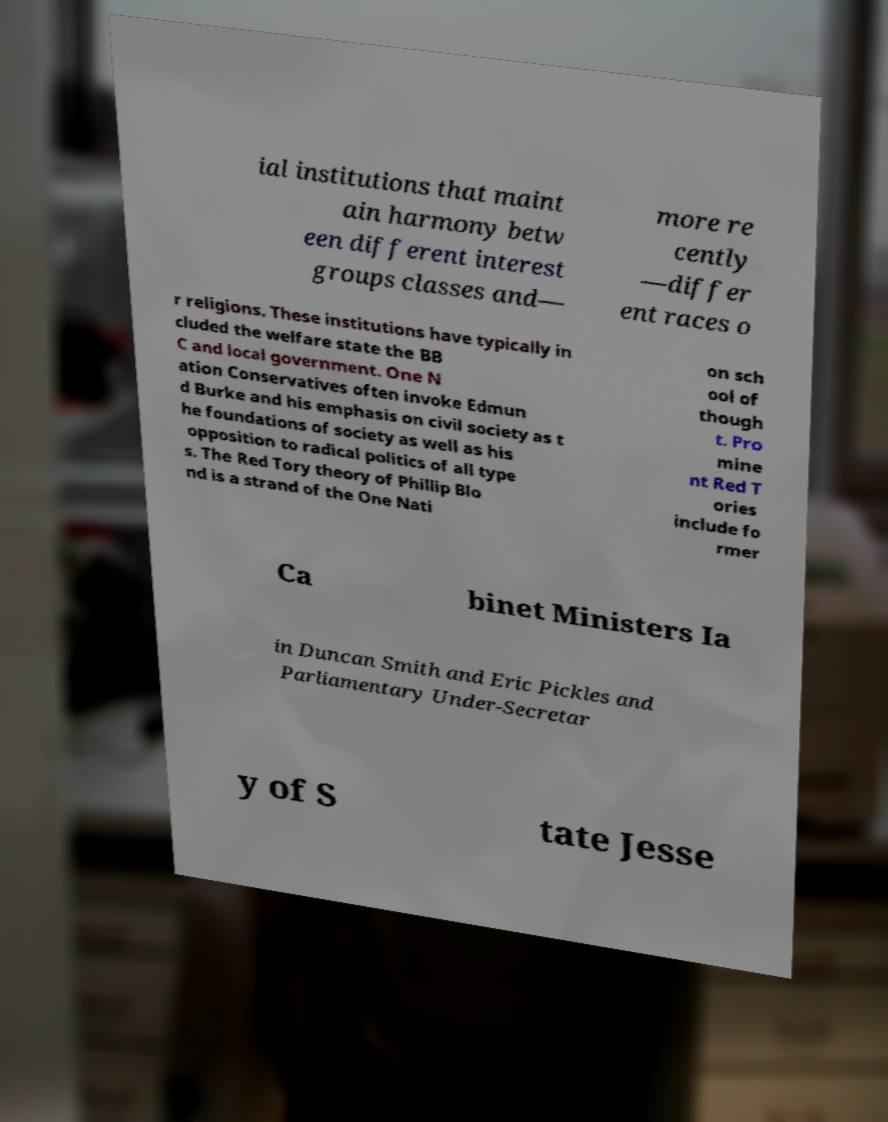Please identify and transcribe the text found in this image. ial institutions that maint ain harmony betw een different interest groups classes and— more re cently —differ ent races o r religions. These institutions have typically in cluded the welfare state the BB C and local government. One N ation Conservatives often invoke Edmun d Burke and his emphasis on civil society as t he foundations of society as well as his opposition to radical politics of all type s. The Red Tory theory of Phillip Blo nd is a strand of the One Nati on sch ool of though t. Pro mine nt Red T ories include fo rmer Ca binet Ministers Ia in Duncan Smith and Eric Pickles and Parliamentary Under-Secretar y of S tate Jesse 